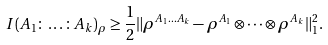Convert formula to latex. <formula><loc_0><loc_0><loc_500><loc_500>I ( A _ { 1 } \colon \dots \colon A _ { k } ) _ { \rho } \geq \frac { 1 } { 2 } \| \rho ^ { A _ { 1 } \dots A _ { k } } - \rho ^ { A _ { 1 } } \otimes \dots \otimes \rho ^ { A _ { k } } \| _ { 1 } ^ { 2 } .</formula> 